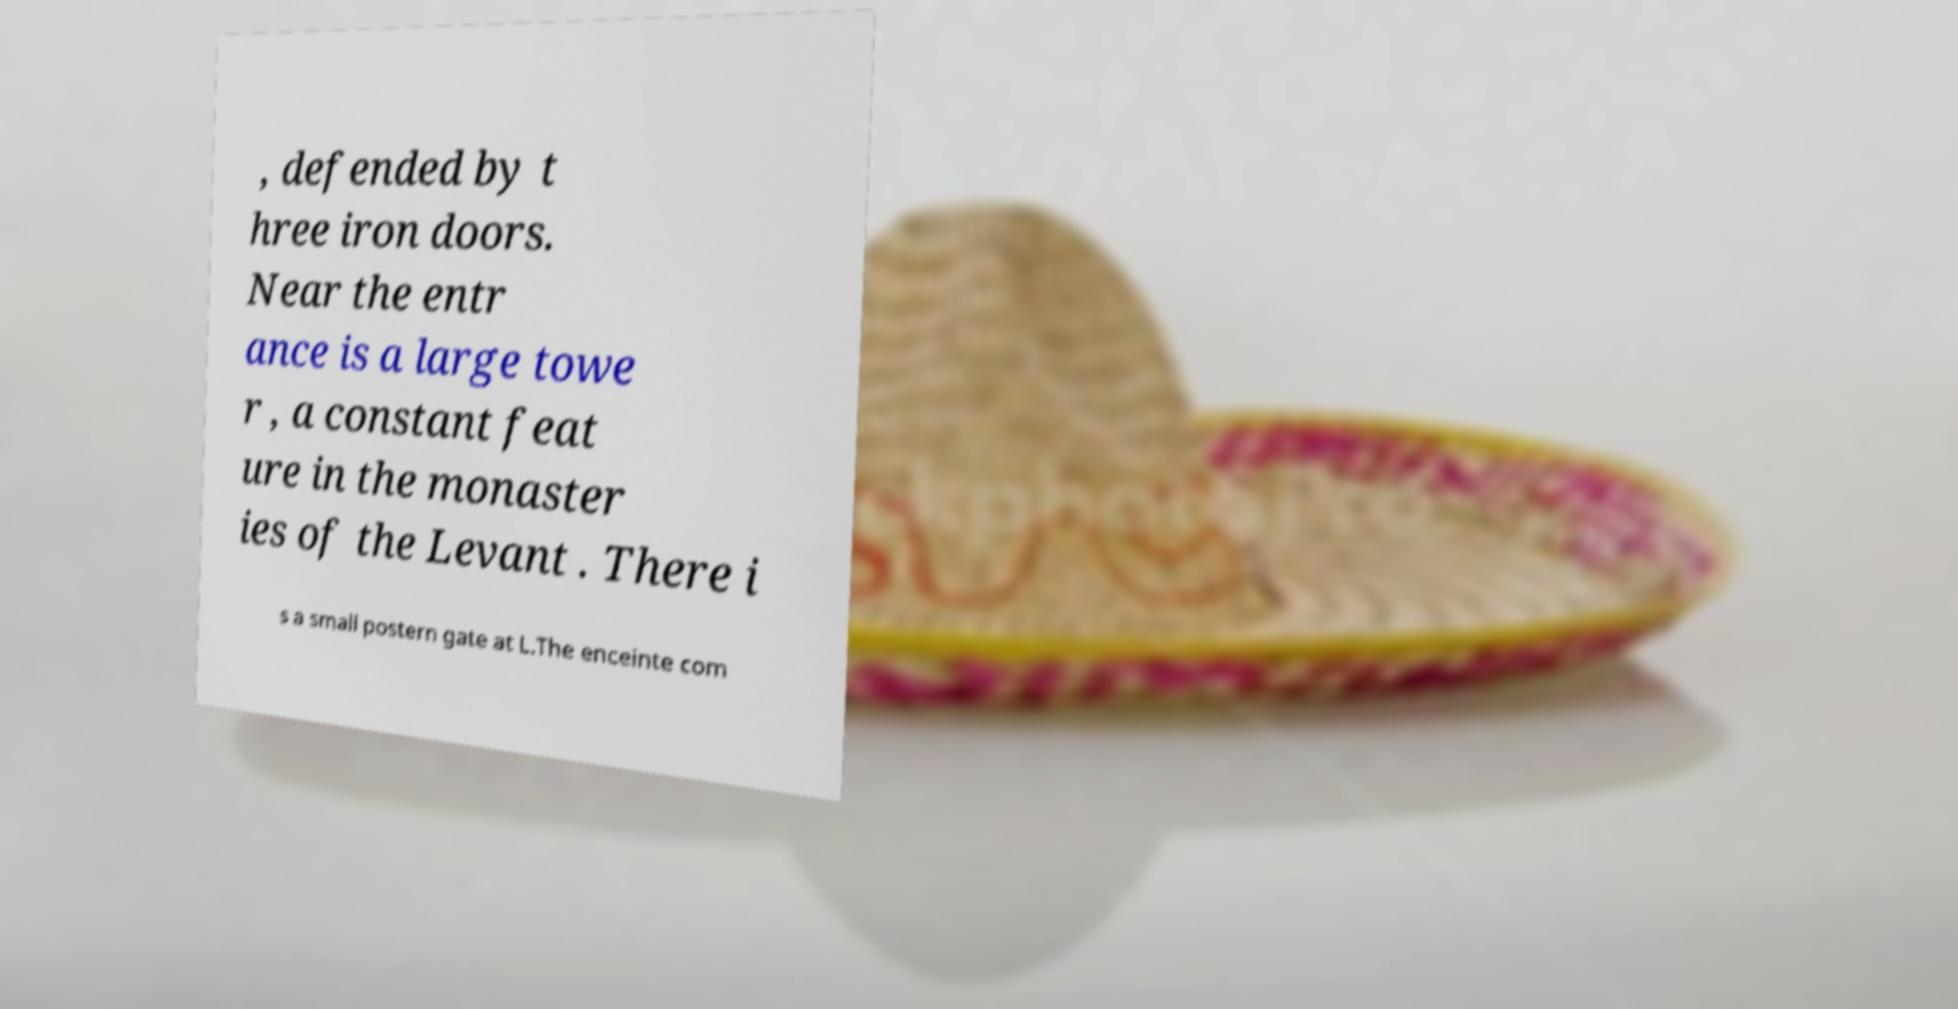Please identify and transcribe the text found in this image. , defended by t hree iron doors. Near the entr ance is a large towe r , a constant feat ure in the monaster ies of the Levant . There i s a small postern gate at L.The enceinte com 